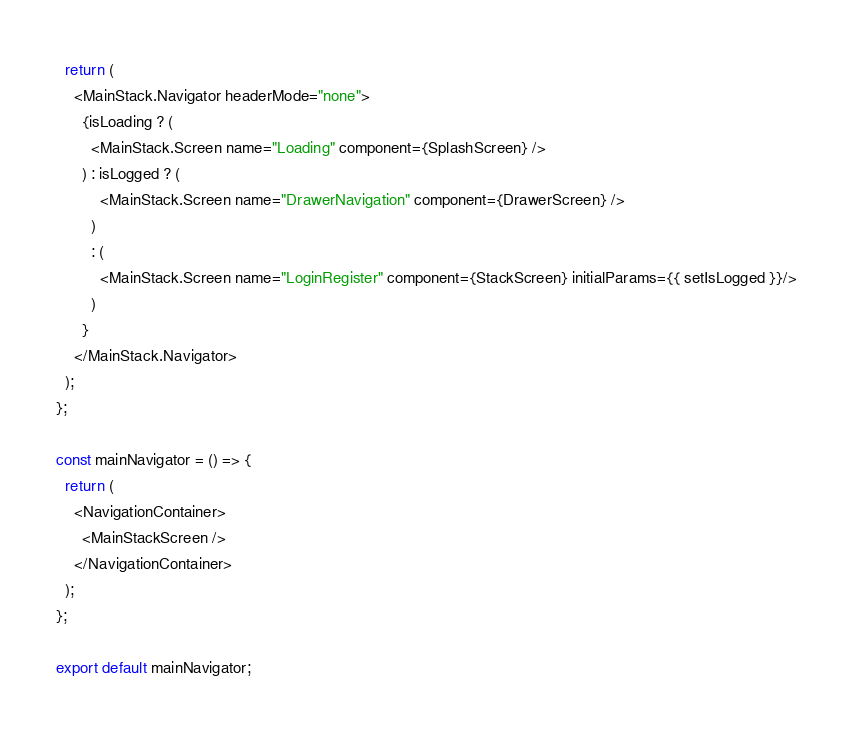Convert code to text. <code><loc_0><loc_0><loc_500><loc_500><_JavaScript_>
  return (
    <MainStack.Navigator headerMode="none">
      {isLoading ? (
        <MainStack.Screen name="Loading" component={SplashScreen} />
      ) : isLogged ? (
          <MainStack.Screen name="DrawerNavigation" component={DrawerScreen} />
        )
        : (
          <MainStack.Screen name="LoginRegister" component={StackScreen} initialParams={{ setIsLogged }}/>
        )
      }
    </MainStack.Navigator>
  );
};

const mainNavigator = () => {
  return (
    <NavigationContainer>
      <MainStackScreen />
    </NavigationContainer>
  );
};

export default mainNavigator;
</code> 